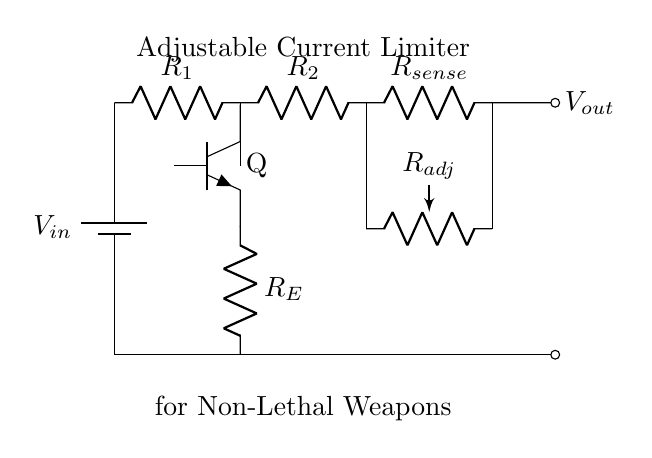What is the type of transistor used in this circuit? The circuit shows an npn transistor indicated by the symbol 'Q'. This type of transistor is commonly used for switching and amplification.
Answer: npn What is the function of R1 in the circuit? R1 is used to limit the current flowing into the base of the transistor. This helps control the amount of current that can be supplied to the load.
Answer: current limiter What is the output voltage denoted as in the circuit? The output voltage is labeled as Vout, which is the voltage available for the load after the current limiter processes the input voltage.
Answer: Vout How is the current limited in this circuit? The current is limited by the resistor R_E and the adjustable resistor R_adj, allowing for the control of current depending on the settings of these components.
Answer: R_E and R_adj What component adjusts the current in the circuit? The potentiometer R_adj is the component used to adjust the resistance, thereby changing the current limit according to user specifications.
Answer: R_adj What type of circuit is this diagram depicting? The circuit diagram represents an adjustable current limiter, which is used to restrict the amount of current supplied to a load, making it suitable for non-lethal applications.
Answer: adjustable current limiter 